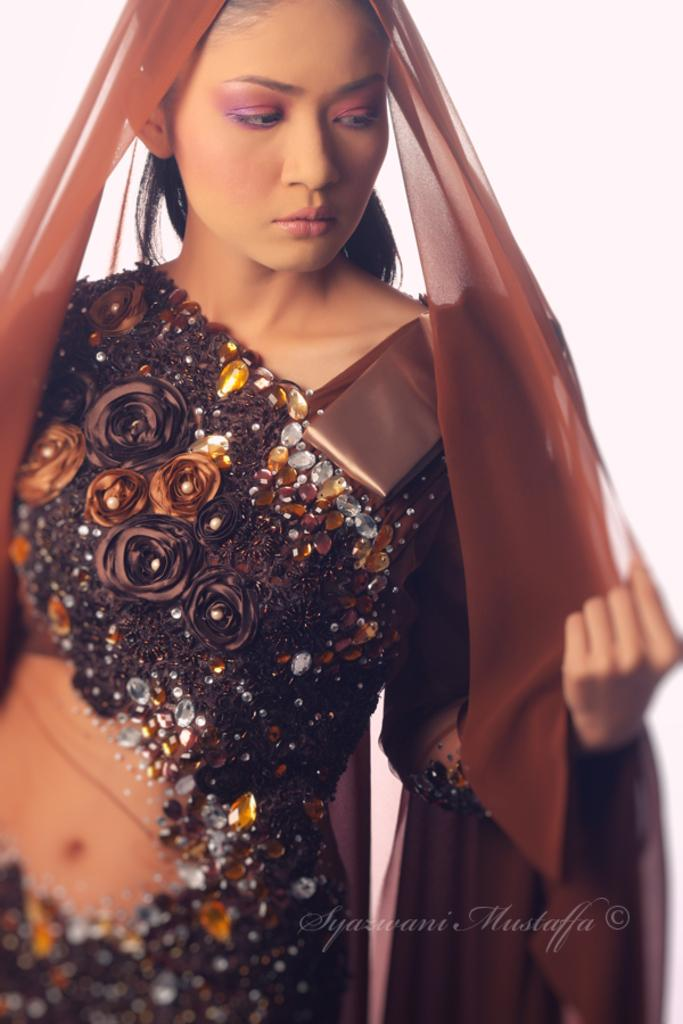Who is present in the image? There is a woman in the image. What type of shoe is the woman using to climb the bushes in the image? There are no bushes or shoes present in the image, and the woman is not shown climbing anything. 